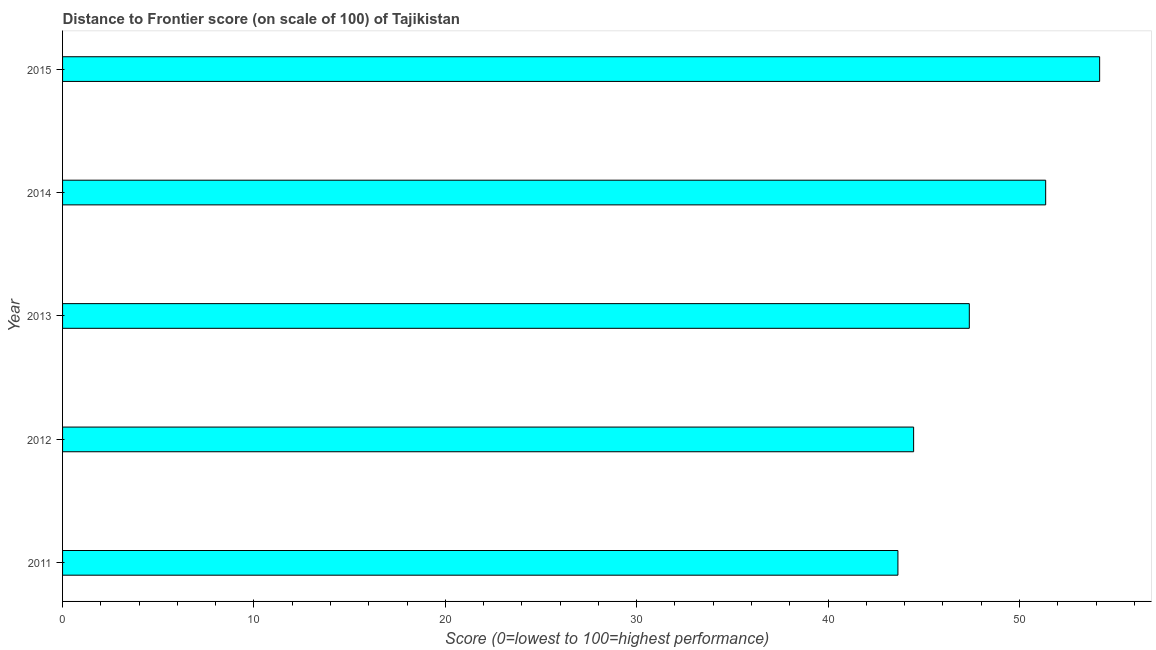Does the graph contain any zero values?
Your response must be concise. No. Does the graph contain grids?
Keep it short and to the point. No. What is the title of the graph?
Provide a short and direct response. Distance to Frontier score (on scale of 100) of Tajikistan. What is the label or title of the X-axis?
Ensure brevity in your answer.  Score (0=lowest to 100=highest performance). What is the distance to frontier score in 2013?
Ensure brevity in your answer.  47.38. Across all years, what is the maximum distance to frontier score?
Ensure brevity in your answer.  54.19. Across all years, what is the minimum distance to frontier score?
Provide a short and direct response. 43.65. In which year was the distance to frontier score maximum?
Make the answer very short. 2015. In which year was the distance to frontier score minimum?
Your answer should be very brief. 2011. What is the sum of the distance to frontier score?
Your response must be concise. 241.06. What is the difference between the distance to frontier score in 2014 and 2015?
Ensure brevity in your answer.  -2.82. What is the average distance to frontier score per year?
Your answer should be very brief. 48.21. What is the median distance to frontier score?
Offer a very short reply. 47.38. Is the difference between the distance to frontier score in 2011 and 2015 greater than the difference between any two years?
Make the answer very short. Yes. What is the difference between the highest and the second highest distance to frontier score?
Your answer should be very brief. 2.82. What is the difference between the highest and the lowest distance to frontier score?
Provide a short and direct response. 10.54. In how many years, is the distance to frontier score greater than the average distance to frontier score taken over all years?
Make the answer very short. 2. How many years are there in the graph?
Give a very brief answer. 5. What is the difference between two consecutive major ticks on the X-axis?
Make the answer very short. 10. What is the Score (0=lowest to 100=highest performance) in 2011?
Your response must be concise. 43.65. What is the Score (0=lowest to 100=highest performance) of 2012?
Keep it short and to the point. 44.47. What is the Score (0=lowest to 100=highest performance) of 2013?
Your response must be concise. 47.38. What is the Score (0=lowest to 100=highest performance) in 2014?
Offer a very short reply. 51.37. What is the Score (0=lowest to 100=highest performance) of 2015?
Keep it short and to the point. 54.19. What is the difference between the Score (0=lowest to 100=highest performance) in 2011 and 2012?
Provide a succinct answer. -0.82. What is the difference between the Score (0=lowest to 100=highest performance) in 2011 and 2013?
Provide a short and direct response. -3.73. What is the difference between the Score (0=lowest to 100=highest performance) in 2011 and 2014?
Provide a short and direct response. -7.72. What is the difference between the Score (0=lowest to 100=highest performance) in 2011 and 2015?
Provide a short and direct response. -10.54. What is the difference between the Score (0=lowest to 100=highest performance) in 2012 and 2013?
Keep it short and to the point. -2.91. What is the difference between the Score (0=lowest to 100=highest performance) in 2012 and 2014?
Your response must be concise. -6.9. What is the difference between the Score (0=lowest to 100=highest performance) in 2012 and 2015?
Your answer should be very brief. -9.72. What is the difference between the Score (0=lowest to 100=highest performance) in 2013 and 2014?
Provide a short and direct response. -3.99. What is the difference between the Score (0=lowest to 100=highest performance) in 2013 and 2015?
Your response must be concise. -6.81. What is the difference between the Score (0=lowest to 100=highest performance) in 2014 and 2015?
Ensure brevity in your answer.  -2.82. What is the ratio of the Score (0=lowest to 100=highest performance) in 2011 to that in 2013?
Offer a very short reply. 0.92. What is the ratio of the Score (0=lowest to 100=highest performance) in 2011 to that in 2014?
Your response must be concise. 0.85. What is the ratio of the Score (0=lowest to 100=highest performance) in 2011 to that in 2015?
Provide a short and direct response. 0.81. What is the ratio of the Score (0=lowest to 100=highest performance) in 2012 to that in 2013?
Offer a terse response. 0.94. What is the ratio of the Score (0=lowest to 100=highest performance) in 2012 to that in 2014?
Make the answer very short. 0.87. What is the ratio of the Score (0=lowest to 100=highest performance) in 2012 to that in 2015?
Give a very brief answer. 0.82. What is the ratio of the Score (0=lowest to 100=highest performance) in 2013 to that in 2014?
Provide a short and direct response. 0.92. What is the ratio of the Score (0=lowest to 100=highest performance) in 2013 to that in 2015?
Your answer should be very brief. 0.87. What is the ratio of the Score (0=lowest to 100=highest performance) in 2014 to that in 2015?
Your answer should be very brief. 0.95. 